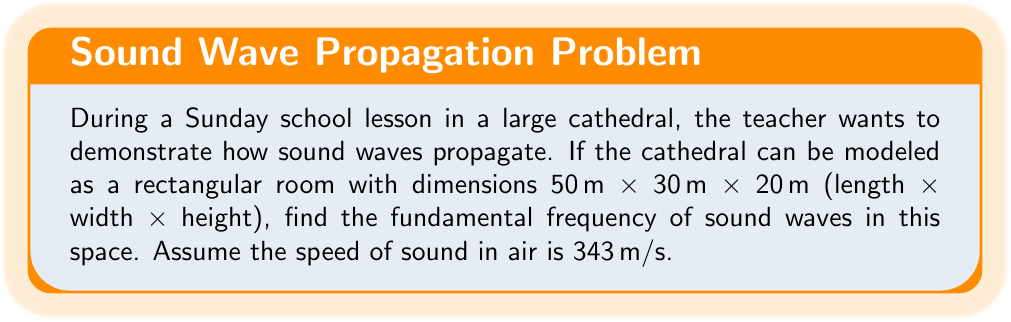Provide a solution to this math problem. To solve this problem, we need to use the wave equation for sound propagation in a three-dimensional space. The wave equation in a rectangular room is given by:

$$\frac{\partial^2 u}{\partial t^2} = c^2 \left(\frac{\partial^2 u}{\partial x^2} + \frac{\partial^2 u}{\partial y^2} + \frac{\partial^2 u}{\partial z^2}\right)$$

where $u$ is the sound pressure, $t$ is time, $c$ is the speed of sound, and $x$, $y$, and $z$ are the spatial coordinates.

The solution to this equation for a rectangular room with dimensions $L_x$, $L_y$, and $L_z$ is:

$$u(x,y,z,t) = \sin\left(\frac{n_x \pi x}{L_x}\right) \sin\left(\frac{n_y \pi y}{L_y}\right) \sin\left(\frac{n_z \pi z}{L_z}\right) \cos(\omega t)$$

where $n_x$, $n_y$, and $n_z$ are integers representing the mode numbers in each direction, and $\omega$ is the angular frequency.

The frequency $f$ is related to the wave numbers by:

$$f = \frac{c}{2} \sqrt{\left(\frac{n_x}{L_x}\right)^2 + \left(\frac{n_y}{L_y}\right)^2 + \left(\frac{n_z}{L_z}\right)^2}$$

The fundamental frequency occurs when $n_x = n_y = n_z = 1$. Substituting the given values:

$L_x = 50$ m
$L_y = 30$ m
$L_z = 20$ m
$c = 343$ m/s

We get:

$$f = \frac{343}{2} \sqrt{\left(\frac{1}{50}\right)^2 + \left(\frac{1}{30}\right)^2 + \left(\frac{1}{20}\right)^2}$$

$$f = 171.5 \sqrt{0.0004 + 0.00111 + 0.0025}$$

$$f = 171.5 \sqrt{0.00361} = 171.5 \times 0.06008 = 10.30$$

Therefore, the fundamental frequency is approximately 10.30 Hz.
Answer: The fundamental frequency of sound waves in the cathedral is approximately 10.30 Hz. 